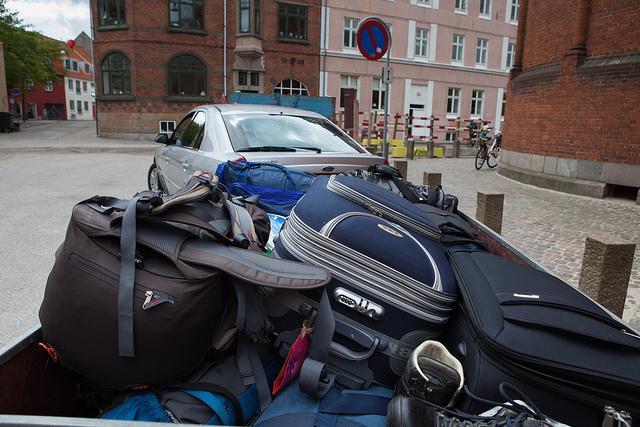What type window is the person who is photographing this luggage looking here? car 